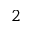Convert formula to latex. <formula><loc_0><loc_0><loc_500><loc_500>2</formula> 